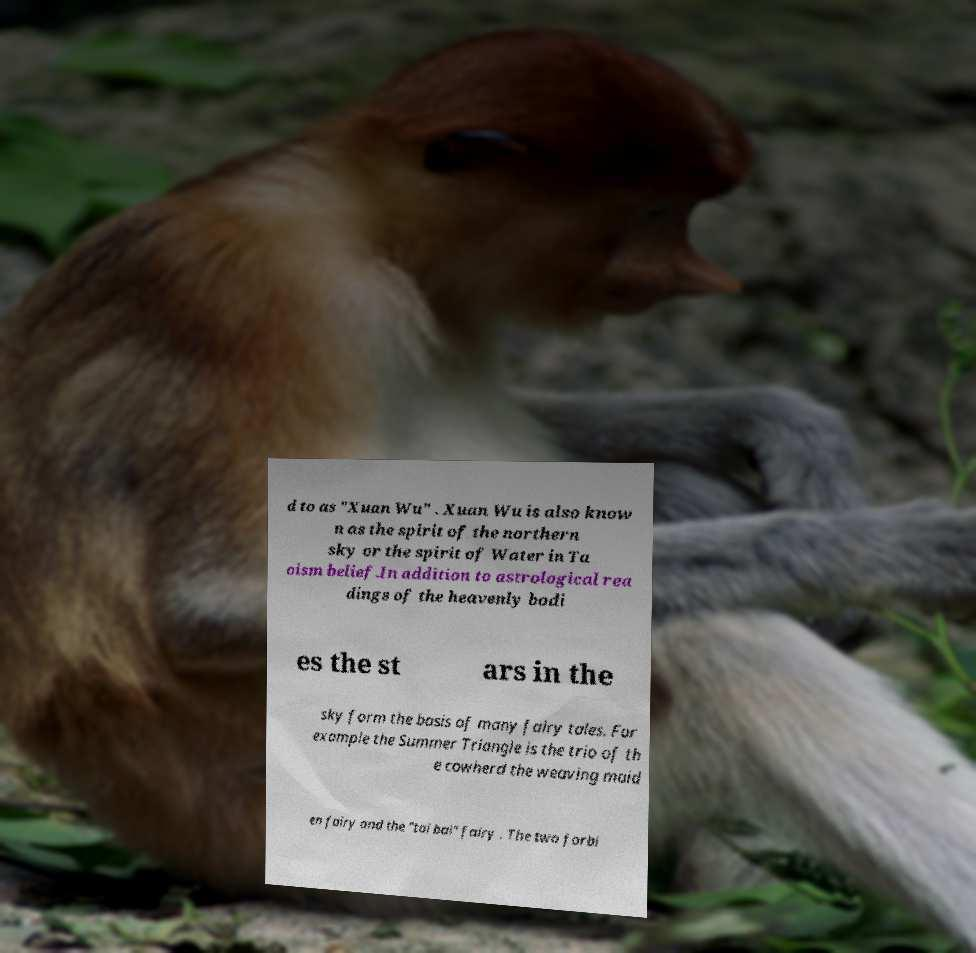Could you assist in decoding the text presented in this image and type it out clearly? d to as "Xuan Wu" . Xuan Wu is also know n as the spirit of the northern sky or the spirit of Water in Ta oism belief.In addition to astrological rea dings of the heavenly bodi es the st ars in the sky form the basis of many fairy tales. For example the Summer Triangle is the trio of th e cowherd the weaving maid en fairy and the "tai bai" fairy . The two forbi 